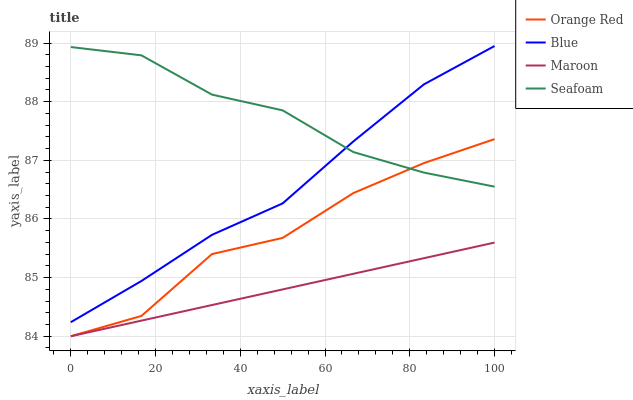Does Maroon have the minimum area under the curve?
Answer yes or no. Yes. Does Seafoam have the maximum area under the curve?
Answer yes or no. Yes. Does Orange Red have the minimum area under the curve?
Answer yes or no. No. Does Orange Red have the maximum area under the curve?
Answer yes or no. No. Is Maroon the smoothest?
Answer yes or no. Yes. Is Orange Red the roughest?
Answer yes or no. Yes. Is Orange Red the smoothest?
Answer yes or no. No. Is Maroon the roughest?
Answer yes or no. No. Does Orange Red have the lowest value?
Answer yes or no. Yes. Does Seafoam have the lowest value?
Answer yes or no. No. Does Blue have the highest value?
Answer yes or no. Yes. Does Orange Red have the highest value?
Answer yes or no. No. Is Maroon less than Blue?
Answer yes or no. Yes. Is Blue greater than Orange Red?
Answer yes or no. Yes. Does Seafoam intersect Blue?
Answer yes or no. Yes. Is Seafoam less than Blue?
Answer yes or no. No. Is Seafoam greater than Blue?
Answer yes or no. No. Does Maroon intersect Blue?
Answer yes or no. No. 